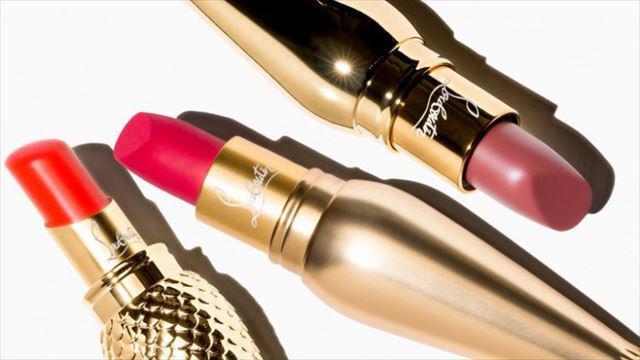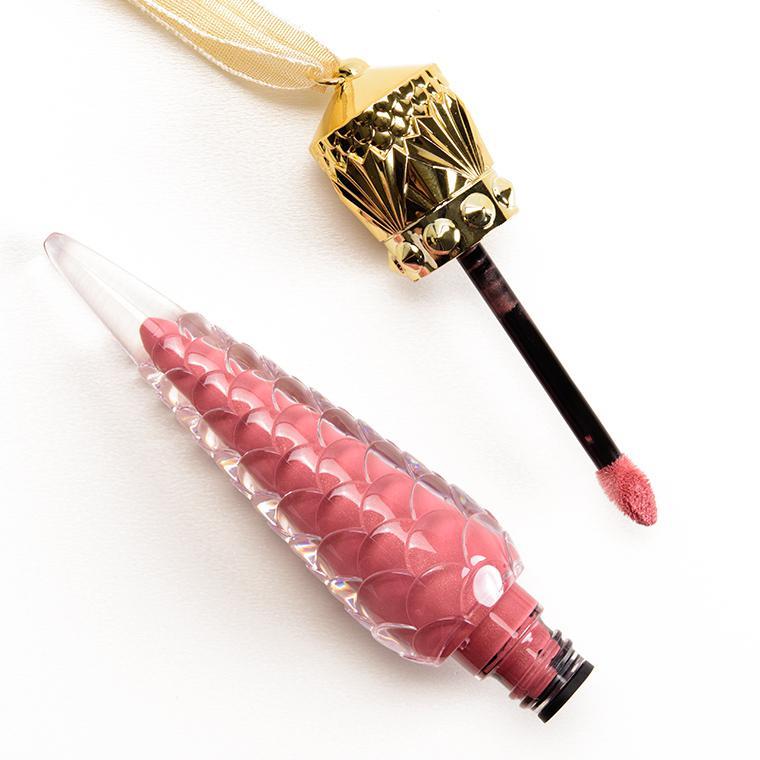The first image is the image on the left, the second image is the image on the right. For the images shown, is this caption "One of the two images shows only one object; an open lip balm, with applicator." true? Answer yes or no. Yes. 